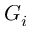<formula> <loc_0><loc_0><loc_500><loc_500>G _ { i }</formula> 